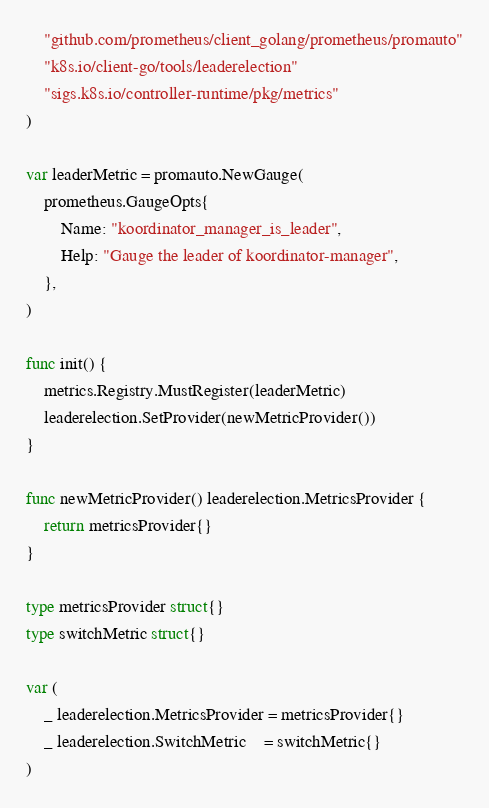Convert code to text. <code><loc_0><loc_0><loc_500><loc_500><_Go_>	"github.com/prometheus/client_golang/prometheus/promauto"
	"k8s.io/client-go/tools/leaderelection"
	"sigs.k8s.io/controller-runtime/pkg/metrics"
)

var leaderMetric = promauto.NewGauge(
	prometheus.GaugeOpts{
		Name: "koordinator_manager_is_leader",
		Help: "Gauge the leader of koordinator-manager",
	},
)

func init() {
	metrics.Registry.MustRegister(leaderMetric)
	leaderelection.SetProvider(newMetricProvider())
}

func newMetricProvider() leaderelection.MetricsProvider {
	return metricsProvider{}
}

type metricsProvider struct{}
type switchMetric struct{}

var (
	_ leaderelection.MetricsProvider = metricsProvider{}
	_ leaderelection.SwitchMetric    = switchMetric{}
)
</code> 